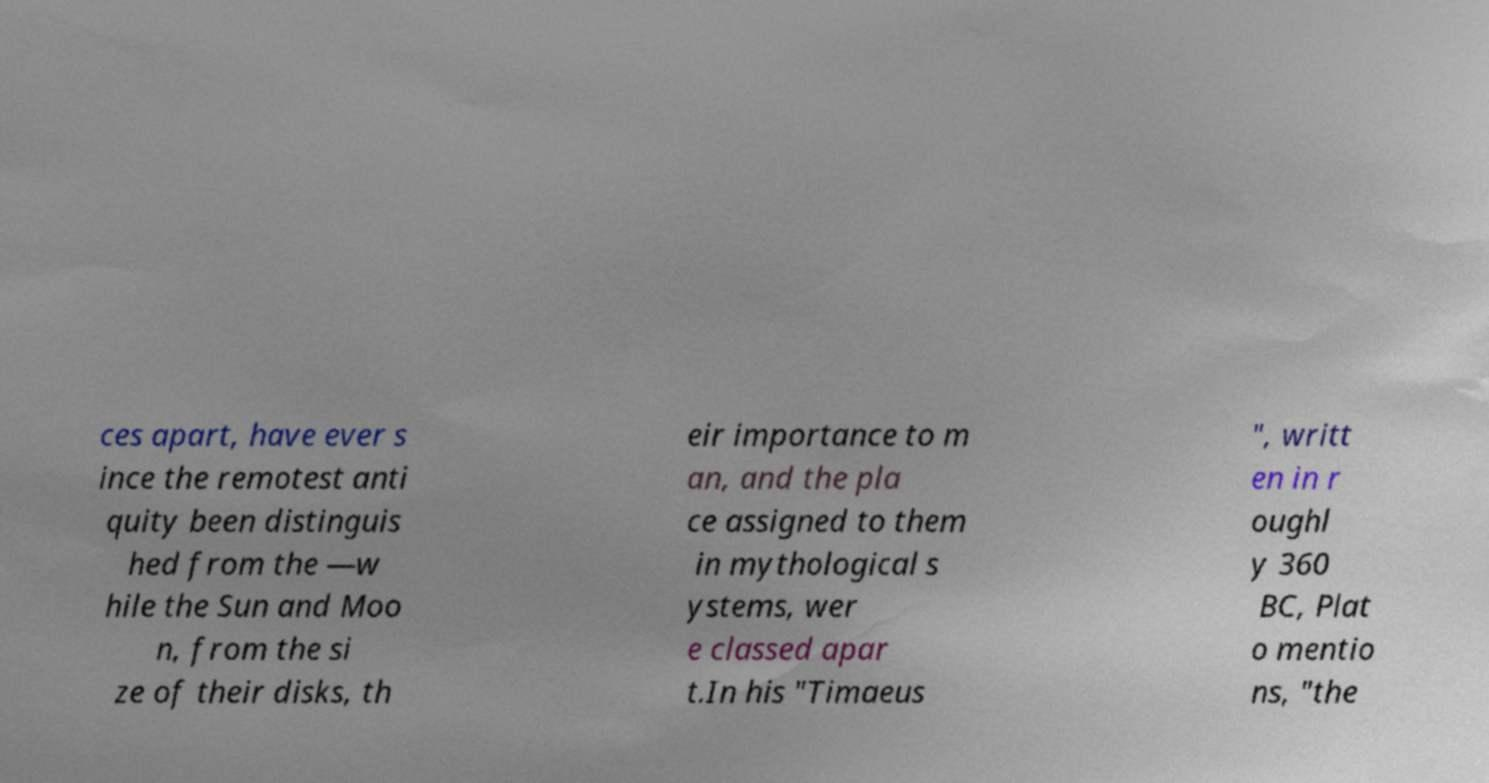Please identify and transcribe the text found in this image. ces apart, have ever s ince the remotest anti quity been distinguis hed from the —w hile the Sun and Moo n, from the si ze of their disks, th eir importance to m an, and the pla ce assigned to them in mythological s ystems, wer e classed apar t.In his "Timaeus ", writt en in r oughl y 360 BC, Plat o mentio ns, "the 